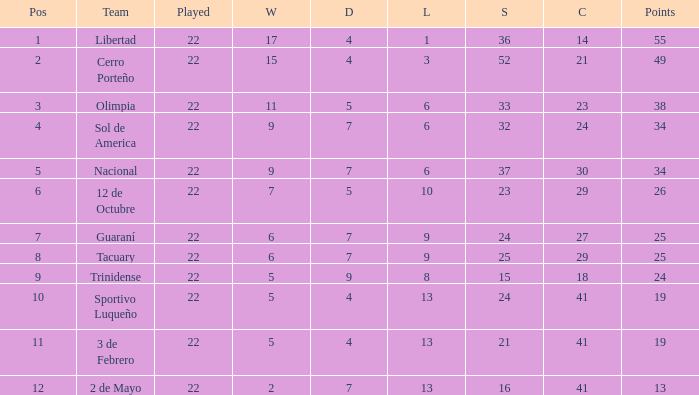Can you parse all the data within this table? {'header': ['Pos', 'Team', 'Played', 'W', 'D', 'L', 'S', 'C', 'Points'], 'rows': [['1', 'Libertad', '22', '17', '4', '1', '36', '14', '55'], ['2', 'Cerro Porteño', '22', '15', '4', '3', '52', '21', '49'], ['3', 'Olimpia', '22', '11', '5', '6', '33', '23', '38'], ['4', 'Sol de America', '22', '9', '7', '6', '32', '24', '34'], ['5', 'Nacional', '22', '9', '7', '6', '37', '30', '34'], ['6', '12 de Octubre', '22', '7', '5', '10', '23', '29', '26'], ['7', 'Guaraní', '22', '6', '7', '9', '24', '27', '25'], ['8', 'Tacuary', '22', '6', '7', '9', '25', '29', '25'], ['9', 'Trinidense', '22', '5', '9', '8', '15', '18', '24'], ['10', 'Sportivo Luqueño', '22', '5', '4', '13', '24', '41', '19'], ['11', '3 de Febrero', '22', '5', '4', '13', '21', '41', '19'], ['12', '2 de Mayo', '22', '2', '7', '13', '16', '41', '13']]} What is the number of draws for the team with more than 8 losses and 13 points? 7.0. 